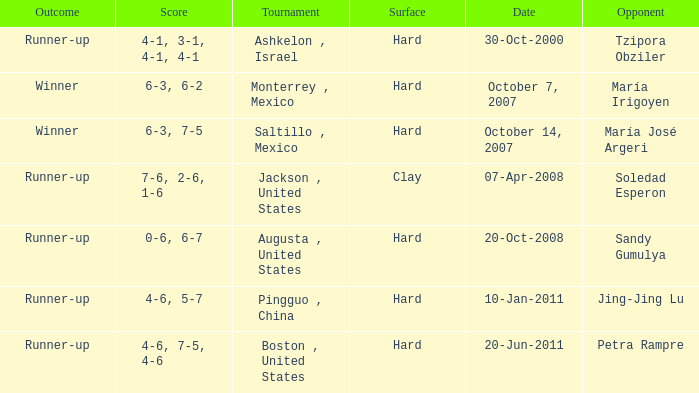Who was the opponent with a score of 4-6, 7-5, 4-6? Petra Rampre. 